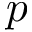<formula> <loc_0><loc_0><loc_500><loc_500>p</formula> 